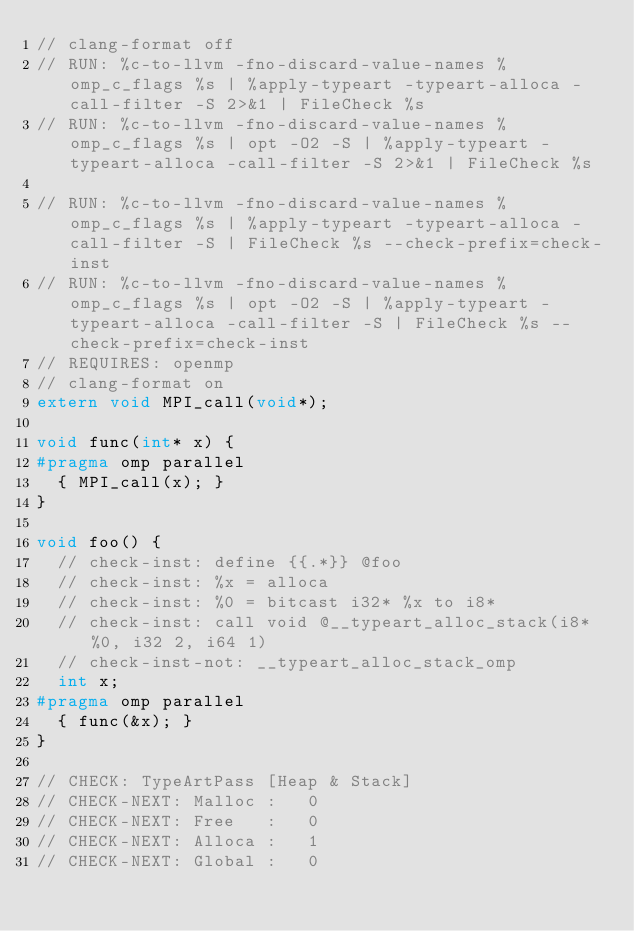Convert code to text. <code><loc_0><loc_0><loc_500><loc_500><_C_>// clang-format off
// RUN: %c-to-llvm -fno-discard-value-names %omp_c_flags %s | %apply-typeart -typeart-alloca -call-filter -S 2>&1 | FileCheck %s
// RUN: %c-to-llvm -fno-discard-value-names %omp_c_flags %s | opt -O2 -S | %apply-typeart -typeart-alloca -call-filter -S 2>&1 | FileCheck %s

// RUN: %c-to-llvm -fno-discard-value-names %omp_c_flags %s | %apply-typeart -typeart-alloca -call-filter -S | FileCheck %s --check-prefix=check-inst
// RUN: %c-to-llvm -fno-discard-value-names %omp_c_flags %s | opt -O2 -S | %apply-typeart -typeart-alloca -call-filter -S | FileCheck %s --check-prefix=check-inst
// REQUIRES: openmp
// clang-format on
extern void MPI_call(void*);

void func(int* x) {
#pragma omp parallel
  { MPI_call(x); }
}

void foo() {
  // check-inst: define {{.*}} @foo
  // check-inst: %x = alloca
  // check-inst: %0 = bitcast i32* %x to i8*
  // check-inst: call void @__typeart_alloc_stack(i8* %0, i32 2, i64 1)
  // check-inst-not: __typeart_alloc_stack_omp
  int x;
#pragma omp parallel
  { func(&x); }
}

// CHECK: TypeArtPass [Heap & Stack]
// CHECK-NEXT: Malloc :   0
// CHECK-NEXT: Free   :   0
// CHECK-NEXT: Alloca :   1
// CHECK-NEXT: Global :   0</code> 